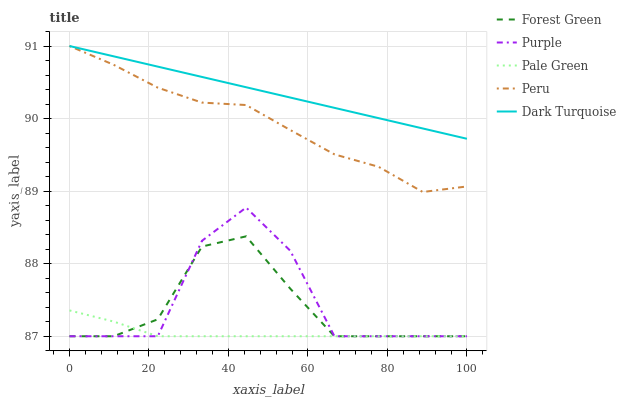Does Pale Green have the minimum area under the curve?
Answer yes or no. Yes. Does Dark Turquoise have the maximum area under the curve?
Answer yes or no. Yes. Does Forest Green have the minimum area under the curve?
Answer yes or no. No. Does Forest Green have the maximum area under the curve?
Answer yes or no. No. Is Dark Turquoise the smoothest?
Answer yes or no. Yes. Is Purple the roughest?
Answer yes or no. Yes. Is Forest Green the smoothest?
Answer yes or no. No. Is Forest Green the roughest?
Answer yes or no. No. Does Purple have the lowest value?
Answer yes or no. Yes. Does Dark Turquoise have the lowest value?
Answer yes or no. No. Does Peru have the highest value?
Answer yes or no. Yes. Does Forest Green have the highest value?
Answer yes or no. No. Is Pale Green less than Peru?
Answer yes or no. Yes. Is Dark Turquoise greater than Forest Green?
Answer yes or no. Yes. Does Purple intersect Pale Green?
Answer yes or no. Yes. Is Purple less than Pale Green?
Answer yes or no. No. Is Purple greater than Pale Green?
Answer yes or no. No. Does Pale Green intersect Peru?
Answer yes or no. No. 